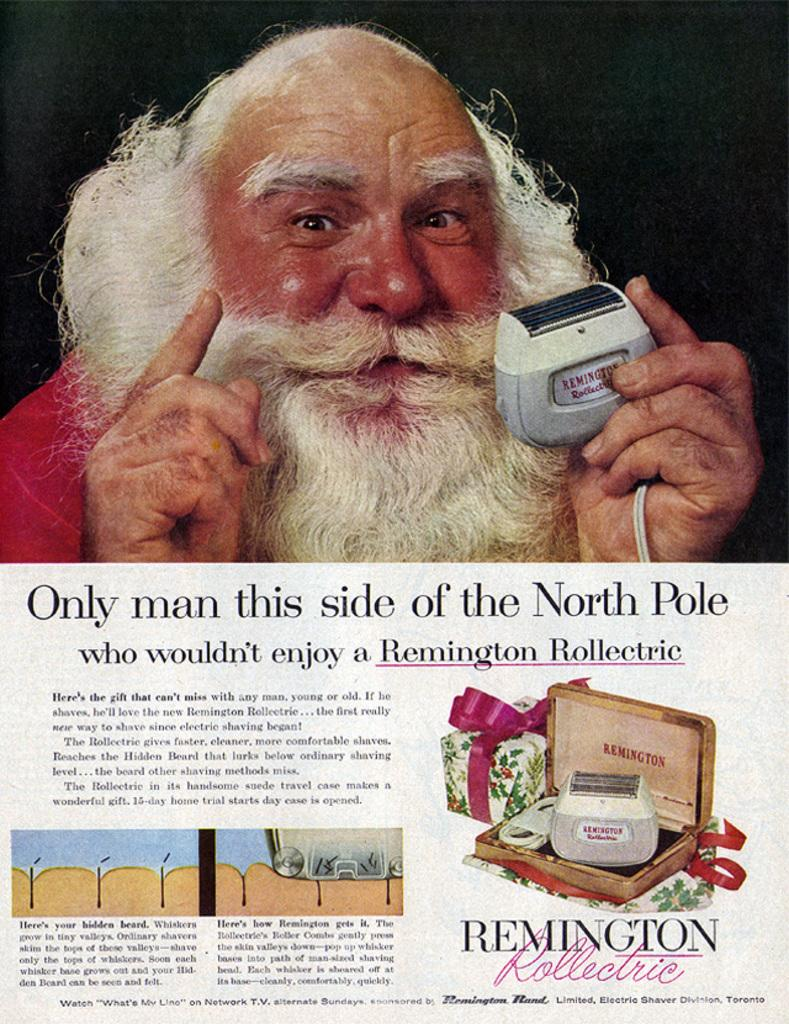What is the main object in the image? There is a paper in the image. What is depicted on the paper? The paper contains a picture of a person and text. Can you describe the additional element on the right side of the image? There is a depiction of a gift box on the right side of the image. What is the tendency of the cork in the image? There is no cork present in the image. What reason does the person in the image have for being depicted on the paper? The image does not provide any information about the reason for depicting the person on the paper. 